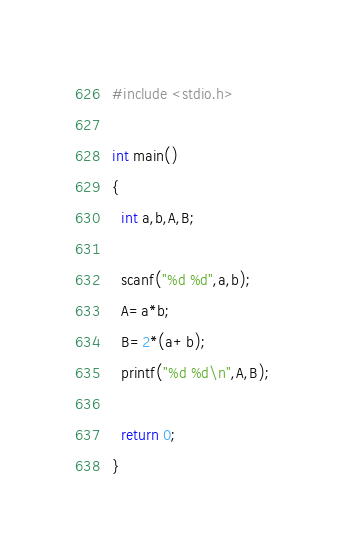Convert code to text. <code><loc_0><loc_0><loc_500><loc_500><_C_>#include <stdio.h>

int main()
{
  int a,b,A,B;
 
  scanf("%d %d",a,b);
  A=a*b;
  B=2*(a+b);
  printf("%d %d\n",A,B);

  return 0;
}</code> 